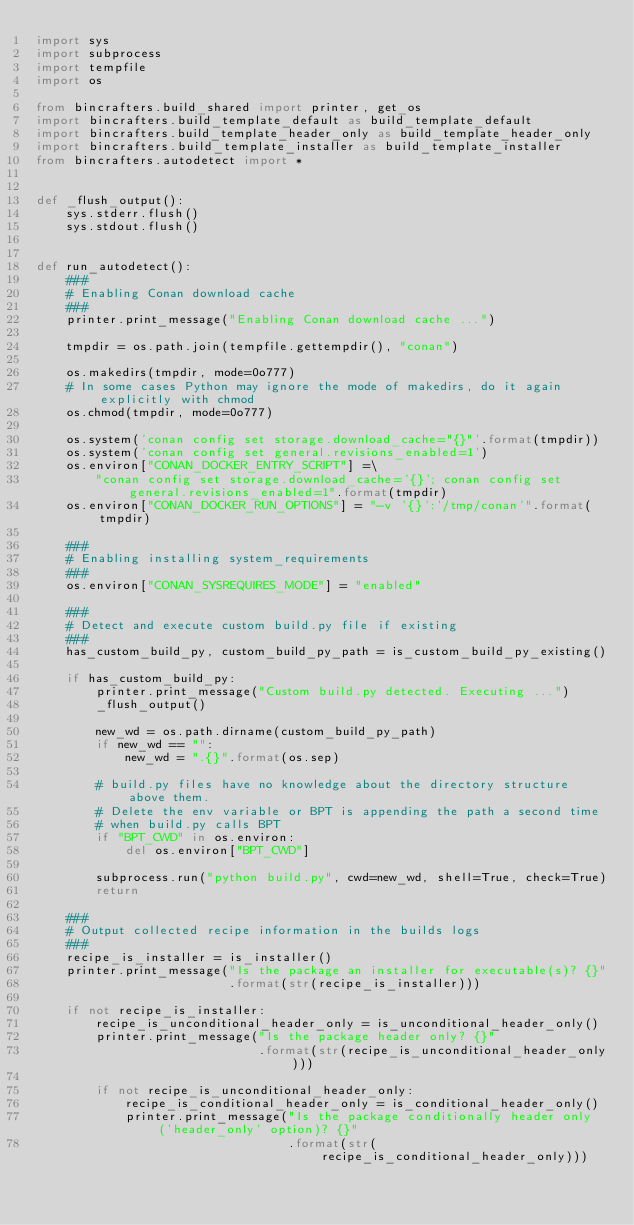<code> <loc_0><loc_0><loc_500><loc_500><_Python_>import sys
import subprocess
import tempfile
import os

from bincrafters.build_shared import printer, get_os
import bincrafters.build_template_default as build_template_default
import bincrafters.build_template_header_only as build_template_header_only
import bincrafters.build_template_installer as build_template_installer
from bincrafters.autodetect import *


def _flush_output():
    sys.stderr.flush()
    sys.stdout.flush()


def run_autodetect():
    ###
    # Enabling Conan download cache
    ###
    printer.print_message("Enabling Conan download cache ...")

    tmpdir = os.path.join(tempfile.gettempdir(), "conan")

    os.makedirs(tmpdir, mode=0o777)
    # In some cases Python may ignore the mode of makedirs, do it again explicitly with chmod
    os.chmod(tmpdir, mode=0o777)

    os.system('conan config set storage.download_cache="{}"'.format(tmpdir))
    os.system('conan config set general.revisions_enabled=1')
    os.environ["CONAN_DOCKER_ENTRY_SCRIPT"] =\
        "conan config set storage.download_cache='{}'; conan config set general.revisions_enabled=1".format(tmpdir)
    os.environ["CONAN_DOCKER_RUN_OPTIONS"] = "-v '{}':'/tmp/conan'".format(tmpdir)

    ###
    # Enabling installing system_requirements
    ###
    os.environ["CONAN_SYSREQUIRES_MODE"] = "enabled"

    ###
    # Detect and execute custom build.py file if existing
    ###
    has_custom_build_py, custom_build_py_path = is_custom_build_py_existing()

    if has_custom_build_py:
        printer.print_message("Custom build.py detected. Executing ...")
        _flush_output()

        new_wd = os.path.dirname(custom_build_py_path)
        if new_wd == "":
            new_wd = ".{}".format(os.sep)

        # build.py files have no knowledge about the directory structure above them.
        # Delete the env variable or BPT is appending the path a second time
        # when build.py calls BPT
        if "BPT_CWD" in os.environ:
            del os.environ["BPT_CWD"]

        subprocess.run("python build.py", cwd=new_wd, shell=True, check=True)
        return

    ###
    # Output collected recipe information in the builds logs
    ###
    recipe_is_installer = is_installer()
    printer.print_message("Is the package an installer for executable(s)? {}"
                          .format(str(recipe_is_installer)))

    if not recipe_is_installer:
        recipe_is_unconditional_header_only = is_unconditional_header_only()
        printer.print_message("Is the package header only? {}"
                              .format(str(recipe_is_unconditional_header_only)))

        if not recipe_is_unconditional_header_only:
            recipe_is_conditional_header_only = is_conditional_header_only()
            printer.print_message("Is the package conditionally header only ('header_only' option)? {}"
                                  .format(str(recipe_is_conditional_header_only)))
</code> 